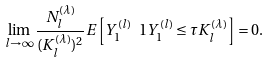Convert formula to latex. <formula><loc_0><loc_0><loc_500><loc_500>\lim _ { l \to \infty } \frac { N _ { l } ^ { ( \lambda ) } } { ( K _ { l } ^ { ( \lambda ) } ) ^ { 2 } } E \left [ Y _ { 1 } ^ { ( l ) } \ 1 { Y _ { 1 } ^ { ( l ) } \leq \tau K _ { l } ^ { ( \lambda ) } } \right ] = 0 .</formula> 